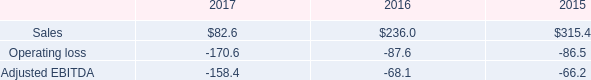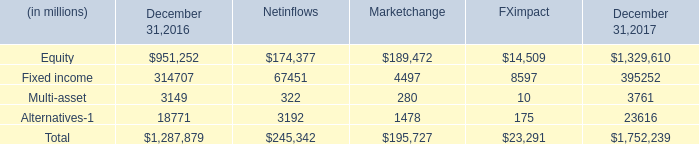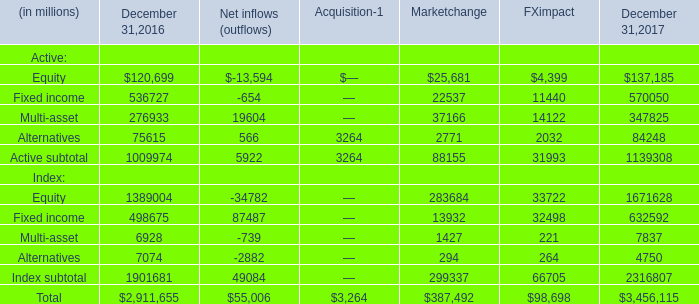What is the sum of Alternatives of December 31,2017, and Equity of December 31,2016 ? 
Computations: (23616.0 + 120699.0)
Answer: 144315.0. 